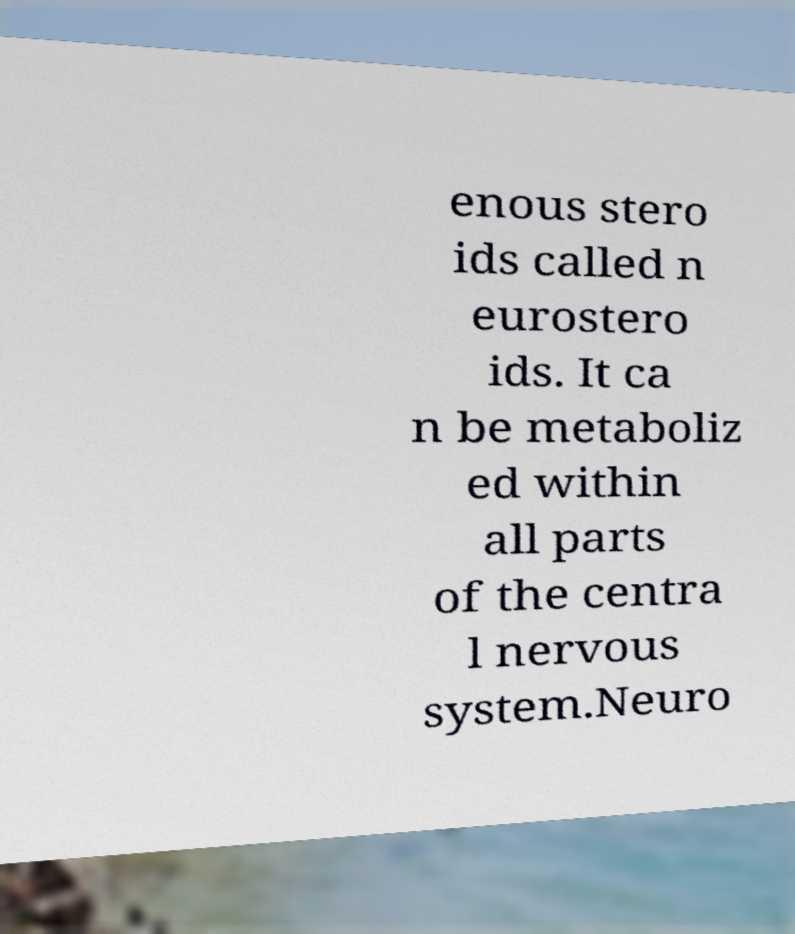What messages or text are displayed in this image? I need them in a readable, typed format. enous stero ids called n eurostero ids. It ca n be metaboliz ed within all parts of the centra l nervous system.Neuro 